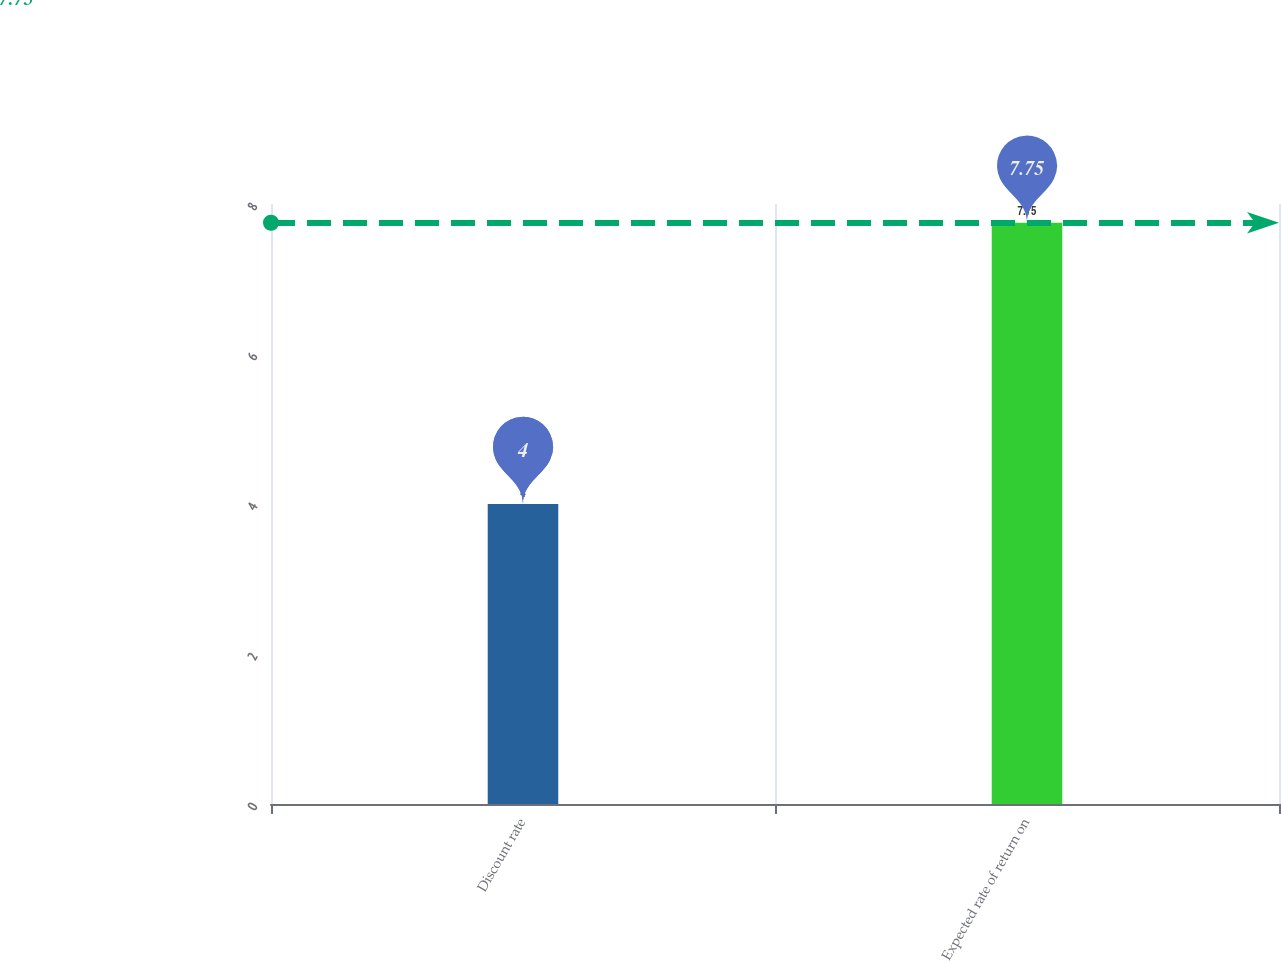Convert chart. <chart><loc_0><loc_0><loc_500><loc_500><bar_chart><fcel>Discount rate<fcel>Expected rate of return on<nl><fcel>4<fcel>7.75<nl></chart> 